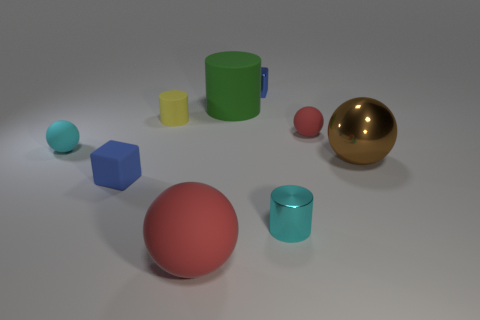Are there any yellow rubber objects?
Provide a short and direct response. Yes. There is a small cyan thing that is in front of the small rubber block; is it the same shape as the red object on the left side of the small metal cube?
Offer a very short reply. No. Are there any tiny cyan objects made of the same material as the brown object?
Provide a short and direct response. Yes. Are the blue block in front of the brown metal object and the brown object made of the same material?
Ensure brevity in your answer.  No. Is the number of big rubber objects in front of the yellow object greater than the number of cyan metal objects to the right of the small red rubber object?
Offer a very short reply. Yes. What color is the matte ball that is the same size as the brown thing?
Keep it short and to the point. Red. Is there another tiny cylinder that has the same color as the shiny cylinder?
Your response must be concise. No. There is a large rubber thing behind the metal sphere; is its color the same as the block right of the large cylinder?
Your response must be concise. No. What is the material of the cyan thing that is on the left side of the cyan cylinder?
Provide a short and direct response. Rubber. There is a large ball that is made of the same material as the tiny red ball; what color is it?
Make the answer very short. Red. 